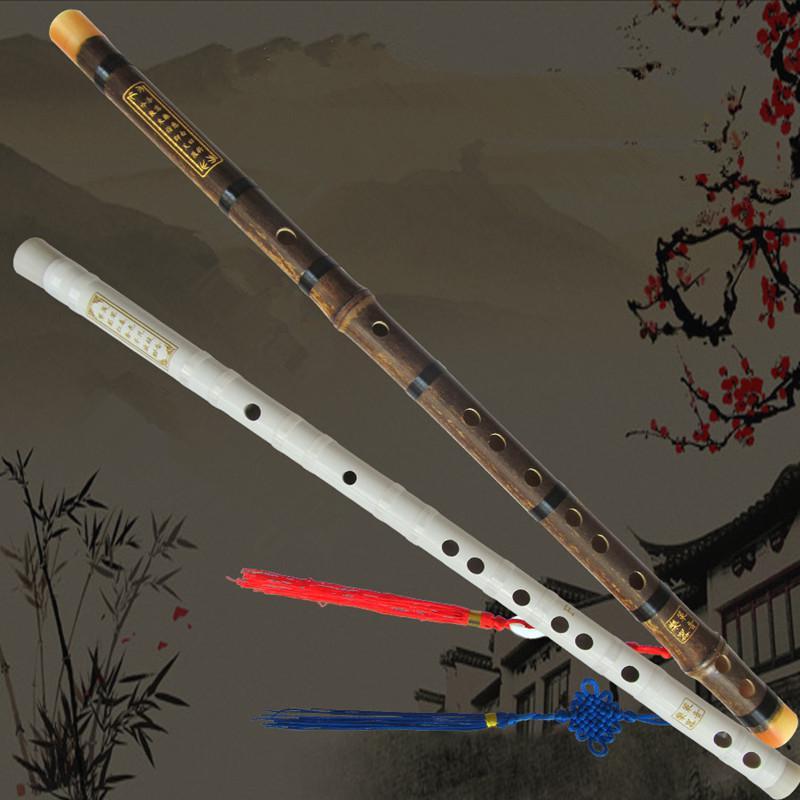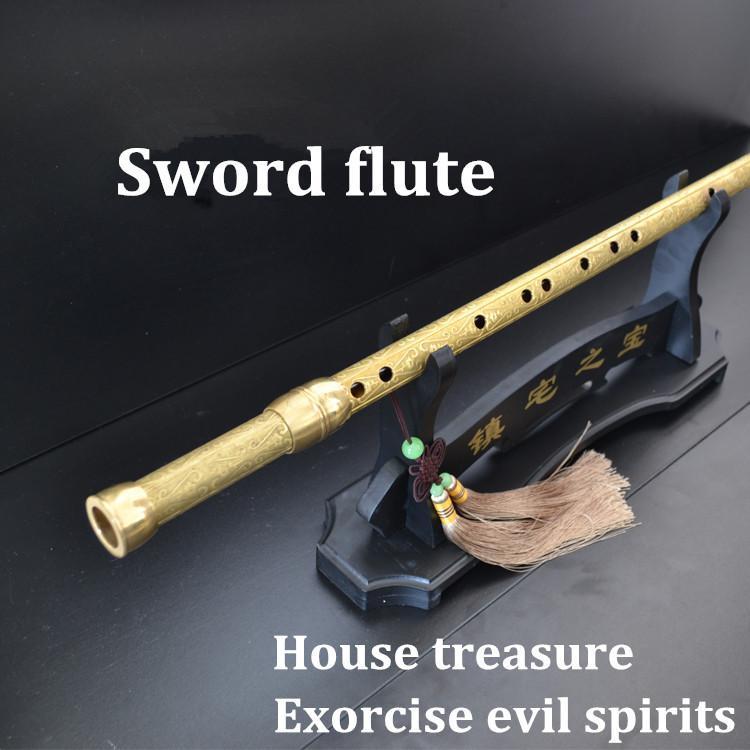The first image is the image on the left, the second image is the image on the right. Analyze the images presented: Is the assertion "There is a white flute." valid? Answer yes or no. Yes. The first image is the image on the left, the second image is the image on the right. Evaluate the accuracy of this statement regarding the images: "The picture on the left shows exactly two flutes side by side.". Is it true? Answer yes or no. Yes. 